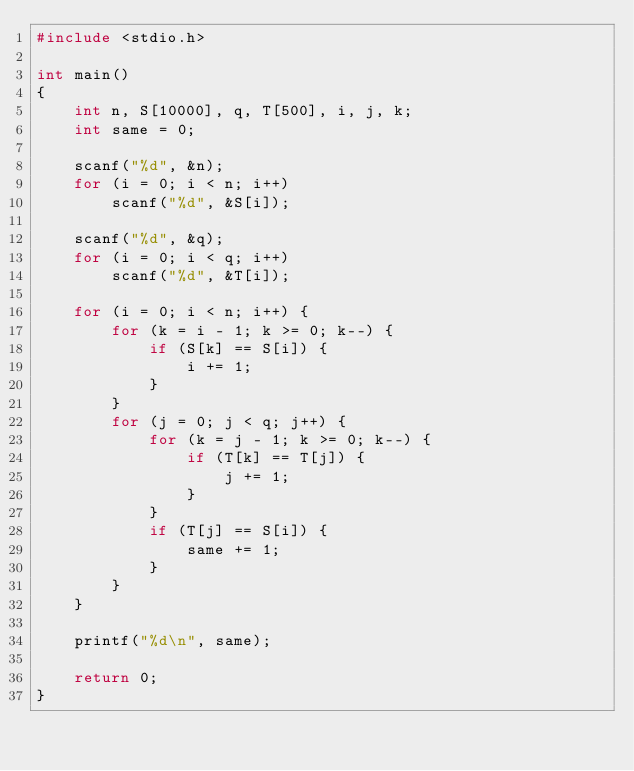<code> <loc_0><loc_0><loc_500><loc_500><_C_>#include <stdio.h>
 
int main()
{
    int n, S[10000], q, T[500], i, j, k;
    int same = 0;

    scanf("%d", &n);
    for (i = 0; i < n; i++)
        scanf("%d", &S[i]);

    scanf("%d", &q);
    for (i = 0; i < q; i++)
        scanf("%d", &T[i]);
   
    for (i = 0; i < n; i++) {
        for (k = i - 1; k >= 0; k--) {
            if (S[k] == S[i]) {
                i += 1;
            }
        }
        for (j = 0; j < q; j++) {
            for (k = j - 1; k >= 0; k--) {
                if (T[k] == T[j]) {
                    j += 1;
                }
            }
            if (T[j] == S[i]) {
                same += 1;
            }
        }
    }

    printf("%d\n", same);

    return 0;
}</code> 